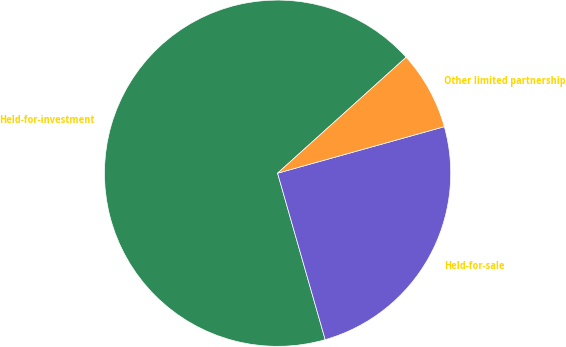Convert chart to OTSL. <chart><loc_0><loc_0><loc_500><loc_500><pie_chart><fcel>Held-for-investment<fcel>Held-for-sale<fcel>Other limited partnership<nl><fcel>67.76%<fcel>24.9%<fcel>7.35%<nl></chart> 